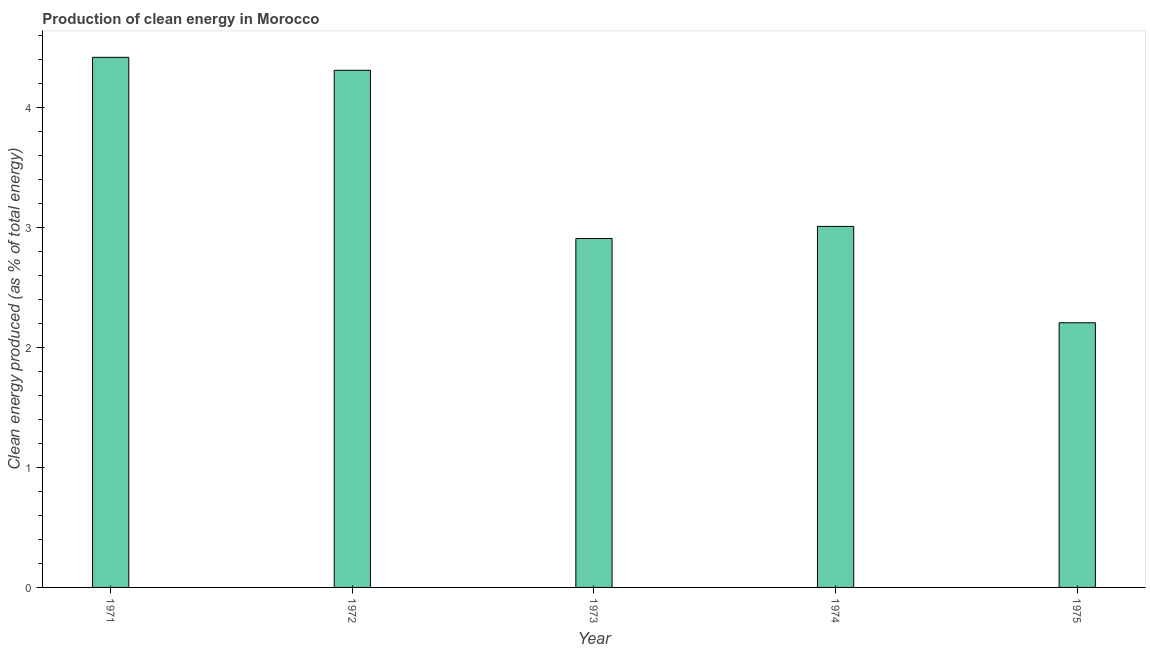Does the graph contain any zero values?
Keep it short and to the point. No. What is the title of the graph?
Keep it short and to the point. Production of clean energy in Morocco. What is the label or title of the X-axis?
Offer a very short reply. Year. What is the label or title of the Y-axis?
Provide a short and direct response. Clean energy produced (as % of total energy). What is the production of clean energy in 1974?
Make the answer very short. 3.01. Across all years, what is the maximum production of clean energy?
Make the answer very short. 4.41. Across all years, what is the minimum production of clean energy?
Ensure brevity in your answer.  2.2. In which year was the production of clean energy minimum?
Keep it short and to the point. 1975. What is the sum of the production of clean energy?
Provide a succinct answer. 16.84. What is the difference between the production of clean energy in 1974 and 1975?
Offer a terse response. 0.8. What is the average production of clean energy per year?
Offer a terse response. 3.37. What is the median production of clean energy?
Your answer should be compact. 3.01. In how many years, is the production of clean energy greater than 2 %?
Provide a short and direct response. 5. What is the ratio of the production of clean energy in 1973 to that in 1975?
Provide a short and direct response. 1.32. Is the production of clean energy in 1971 less than that in 1974?
Offer a terse response. No. What is the difference between the highest and the second highest production of clean energy?
Your answer should be very brief. 0.11. What is the difference between the highest and the lowest production of clean energy?
Your answer should be compact. 2.21. How many bars are there?
Ensure brevity in your answer.  5. Are all the bars in the graph horizontal?
Give a very brief answer. No. What is the Clean energy produced (as % of total energy) in 1971?
Keep it short and to the point. 4.41. What is the Clean energy produced (as % of total energy) of 1972?
Keep it short and to the point. 4.31. What is the Clean energy produced (as % of total energy) in 1973?
Keep it short and to the point. 2.91. What is the Clean energy produced (as % of total energy) of 1974?
Your response must be concise. 3.01. What is the Clean energy produced (as % of total energy) in 1975?
Offer a very short reply. 2.2. What is the difference between the Clean energy produced (as % of total energy) in 1971 and 1972?
Provide a short and direct response. 0.11. What is the difference between the Clean energy produced (as % of total energy) in 1971 and 1973?
Ensure brevity in your answer.  1.51. What is the difference between the Clean energy produced (as % of total energy) in 1971 and 1974?
Give a very brief answer. 1.41. What is the difference between the Clean energy produced (as % of total energy) in 1971 and 1975?
Provide a succinct answer. 2.21. What is the difference between the Clean energy produced (as % of total energy) in 1972 and 1973?
Your answer should be very brief. 1.4. What is the difference between the Clean energy produced (as % of total energy) in 1972 and 1974?
Ensure brevity in your answer.  1.3. What is the difference between the Clean energy produced (as % of total energy) in 1972 and 1975?
Your response must be concise. 2.1. What is the difference between the Clean energy produced (as % of total energy) in 1973 and 1974?
Make the answer very short. -0.1. What is the difference between the Clean energy produced (as % of total energy) in 1973 and 1975?
Offer a terse response. 0.7. What is the difference between the Clean energy produced (as % of total energy) in 1974 and 1975?
Your answer should be compact. 0.8. What is the ratio of the Clean energy produced (as % of total energy) in 1971 to that in 1972?
Give a very brief answer. 1.02. What is the ratio of the Clean energy produced (as % of total energy) in 1971 to that in 1973?
Provide a short and direct response. 1.52. What is the ratio of the Clean energy produced (as % of total energy) in 1971 to that in 1974?
Ensure brevity in your answer.  1.47. What is the ratio of the Clean energy produced (as % of total energy) in 1971 to that in 1975?
Your answer should be very brief. 2. What is the ratio of the Clean energy produced (as % of total energy) in 1972 to that in 1973?
Offer a very short reply. 1.48. What is the ratio of the Clean energy produced (as % of total energy) in 1972 to that in 1974?
Keep it short and to the point. 1.43. What is the ratio of the Clean energy produced (as % of total energy) in 1972 to that in 1975?
Give a very brief answer. 1.95. What is the ratio of the Clean energy produced (as % of total energy) in 1973 to that in 1974?
Provide a succinct answer. 0.97. What is the ratio of the Clean energy produced (as % of total energy) in 1973 to that in 1975?
Give a very brief answer. 1.32. What is the ratio of the Clean energy produced (as % of total energy) in 1974 to that in 1975?
Give a very brief answer. 1.36. 